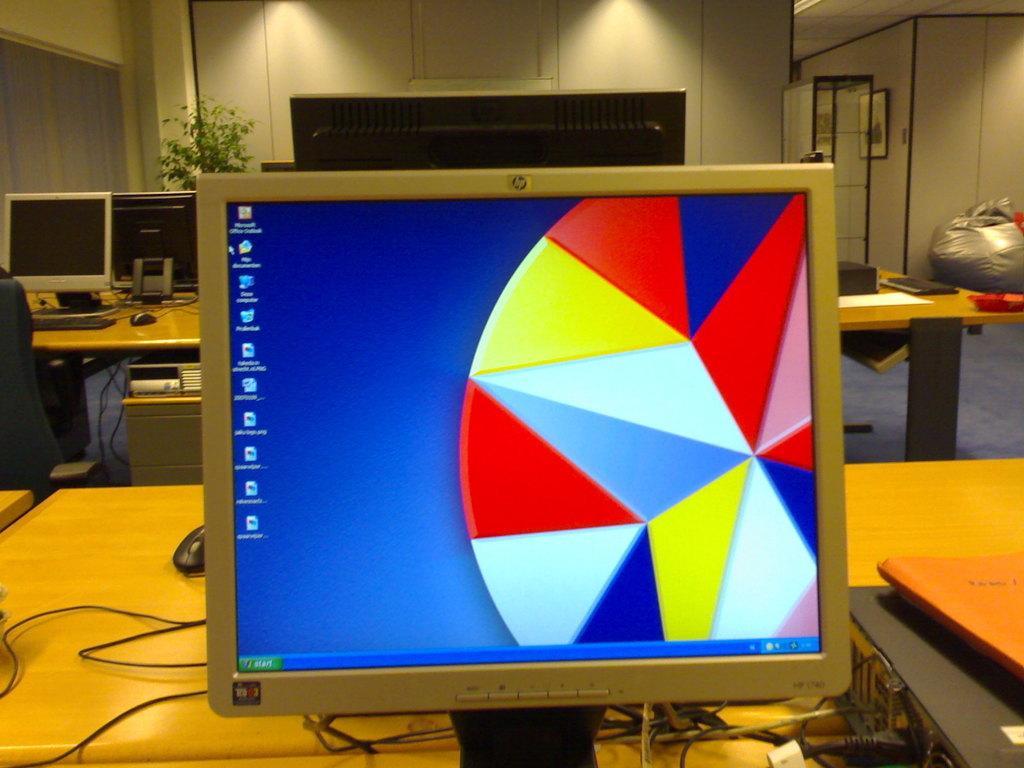Can you describe this image briefly? In this image there are tables and we can see computers, mouses, keyboards and wires placed on the tables. In the background there is a wall, bean bag and a curtain. We can see frames placed on the wall. 